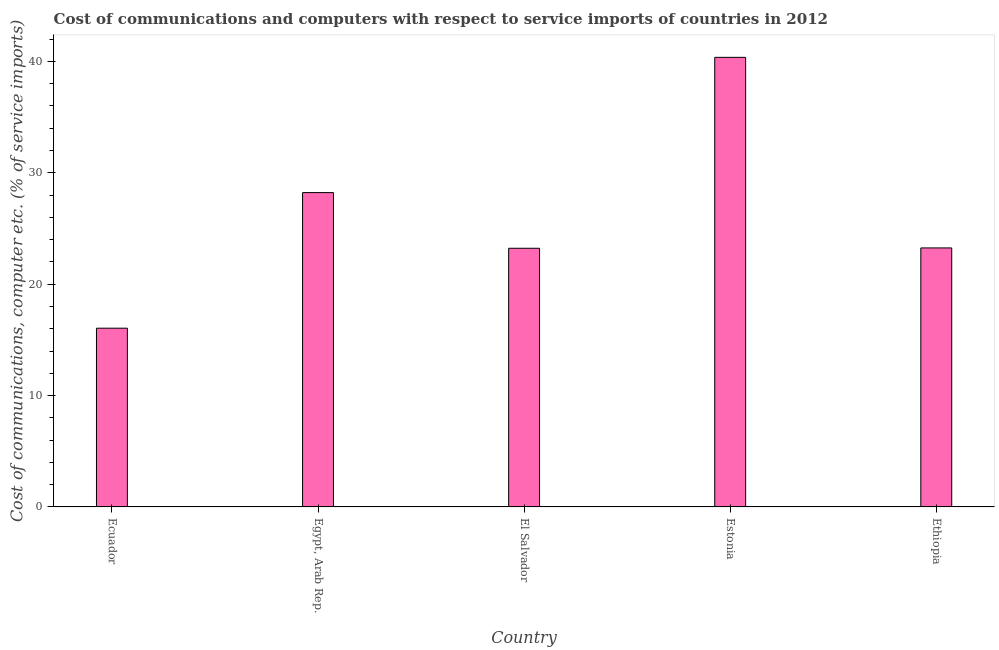Does the graph contain grids?
Make the answer very short. No. What is the title of the graph?
Keep it short and to the point. Cost of communications and computers with respect to service imports of countries in 2012. What is the label or title of the X-axis?
Offer a very short reply. Country. What is the label or title of the Y-axis?
Your answer should be compact. Cost of communications, computer etc. (% of service imports). What is the cost of communications and computer in Estonia?
Your answer should be very brief. 40.37. Across all countries, what is the maximum cost of communications and computer?
Offer a very short reply. 40.37. Across all countries, what is the minimum cost of communications and computer?
Offer a terse response. 16.05. In which country was the cost of communications and computer maximum?
Give a very brief answer. Estonia. In which country was the cost of communications and computer minimum?
Your answer should be compact. Ecuador. What is the sum of the cost of communications and computer?
Offer a terse response. 131.11. What is the difference between the cost of communications and computer in El Salvador and Estonia?
Give a very brief answer. -17.14. What is the average cost of communications and computer per country?
Provide a succinct answer. 26.22. What is the median cost of communications and computer?
Make the answer very short. 23.25. What is the ratio of the cost of communications and computer in Estonia to that in Ethiopia?
Your answer should be compact. 1.74. What is the difference between the highest and the second highest cost of communications and computer?
Give a very brief answer. 12.14. What is the difference between the highest and the lowest cost of communications and computer?
Make the answer very short. 24.32. In how many countries, is the cost of communications and computer greater than the average cost of communications and computer taken over all countries?
Ensure brevity in your answer.  2. How many bars are there?
Your response must be concise. 5. Are all the bars in the graph horizontal?
Offer a very short reply. No. Are the values on the major ticks of Y-axis written in scientific E-notation?
Offer a terse response. No. What is the Cost of communications, computer etc. (% of service imports) of Ecuador?
Provide a short and direct response. 16.05. What is the Cost of communications, computer etc. (% of service imports) in Egypt, Arab Rep.?
Your answer should be very brief. 28.22. What is the Cost of communications, computer etc. (% of service imports) in El Salvador?
Your response must be concise. 23.22. What is the Cost of communications, computer etc. (% of service imports) in Estonia?
Provide a short and direct response. 40.37. What is the Cost of communications, computer etc. (% of service imports) in Ethiopia?
Keep it short and to the point. 23.25. What is the difference between the Cost of communications, computer etc. (% of service imports) in Ecuador and Egypt, Arab Rep.?
Your response must be concise. -12.18. What is the difference between the Cost of communications, computer etc. (% of service imports) in Ecuador and El Salvador?
Provide a short and direct response. -7.18. What is the difference between the Cost of communications, computer etc. (% of service imports) in Ecuador and Estonia?
Keep it short and to the point. -24.32. What is the difference between the Cost of communications, computer etc. (% of service imports) in Ecuador and Ethiopia?
Ensure brevity in your answer.  -7.21. What is the difference between the Cost of communications, computer etc. (% of service imports) in Egypt, Arab Rep. and El Salvador?
Your answer should be compact. 5. What is the difference between the Cost of communications, computer etc. (% of service imports) in Egypt, Arab Rep. and Estonia?
Offer a terse response. -12.14. What is the difference between the Cost of communications, computer etc. (% of service imports) in Egypt, Arab Rep. and Ethiopia?
Provide a succinct answer. 4.97. What is the difference between the Cost of communications, computer etc. (% of service imports) in El Salvador and Estonia?
Provide a short and direct response. -17.14. What is the difference between the Cost of communications, computer etc. (% of service imports) in El Salvador and Ethiopia?
Provide a succinct answer. -0.03. What is the difference between the Cost of communications, computer etc. (% of service imports) in Estonia and Ethiopia?
Keep it short and to the point. 17.11. What is the ratio of the Cost of communications, computer etc. (% of service imports) in Ecuador to that in Egypt, Arab Rep.?
Offer a terse response. 0.57. What is the ratio of the Cost of communications, computer etc. (% of service imports) in Ecuador to that in El Salvador?
Give a very brief answer. 0.69. What is the ratio of the Cost of communications, computer etc. (% of service imports) in Ecuador to that in Estonia?
Give a very brief answer. 0.4. What is the ratio of the Cost of communications, computer etc. (% of service imports) in Ecuador to that in Ethiopia?
Ensure brevity in your answer.  0.69. What is the ratio of the Cost of communications, computer etc. (% of service imports) in Egypt, Arab Rep. to that in El Salvador?
Offer a terse response. 1.22. What is the ratio of the Cost of communications, computer etc. (% of service imports) in Egypt, Arab Rep. to that in Estonia?
Make the answer very short. 0.7. What is the ratio of the Cost of communications, computer etc. (% of service imports) in Egypt, Arab Rep. to that in Ethiopia?
Your answer should be very brief. 1.21. What is the ratio of the Cost of communications, computer etc. (% of service imports) in El Salvador to that in Estonia?
Offer a terse response. 0.57. What is the ratio of the Cost of communications, computer etc. (% of service imports) in El Salvador to that in Ethiopia?
Your answer should be compact. 1. What is the ratio of the Cost of communications, computer etc. (% of service imports) in Estonia to that in Ethiopia?
Offer a terse response. 1.74. 